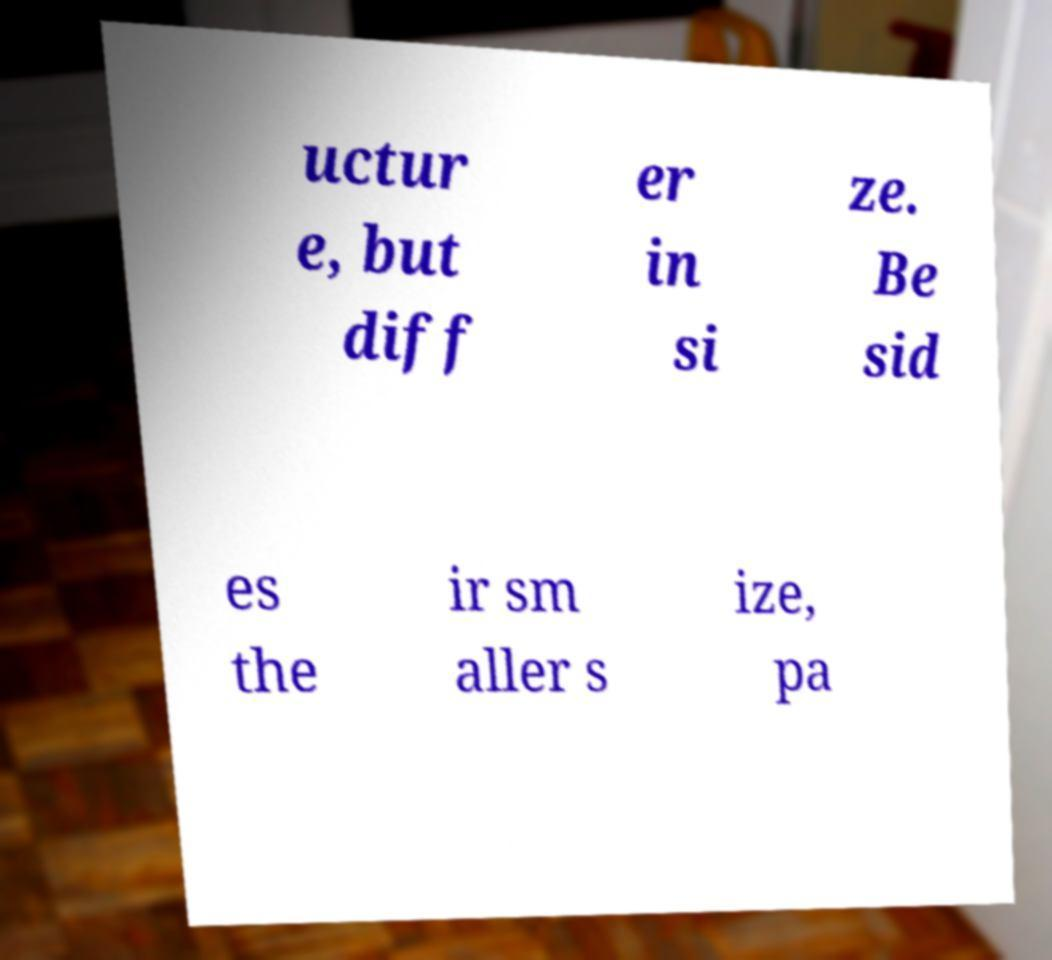Please read and relay the text visible in this image. What does it say? uctur e, but diff er in si ze. Be sid es the ir sm aller s ize, pa 